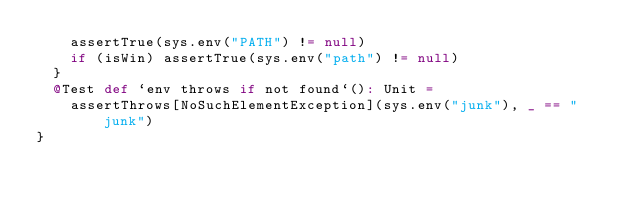<code> <loc_0><loc_0><loc_500><loc_500><_Scala_>    assertTrue(sys.env("PATH") != null)
    if (isWin) assertTrue(sys.env("path") != null)
  }
  @Test def `env throws if not found`(): Unit =
    assertThrows[NoSuchElementException](sys.env("junk"), _ == "junk")
}
</code> 